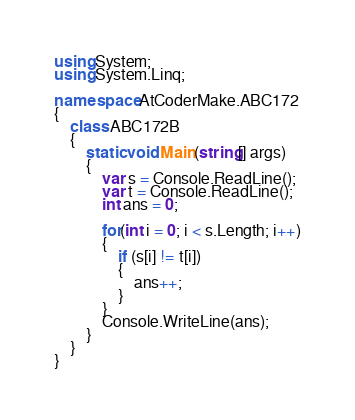<code> <loc_0><loc_0><loc_500><loc_500><_C#_>using System;
using System.Linq;

namespace AtCoderMake.ABC172
{
    class ABC172B
    {
        static void Main(string[] args)
        {
            var s = Console.ReadLine();
            var t = Console.ReadLine();
            int ans = 0;
            
            for(int i = 0; i < s.Length; i++)
            {
                if (s[i] != t[i])
                {
                    ans++;
                }
            }
            Console.WriteLine(ans);
        }
    }
}
</code> 